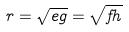Convert formula to latex. <formula><loc_0><loc_0><loc_500><loc_500>r = \sqrt { e g } = \sqrt { f h }</formula> 